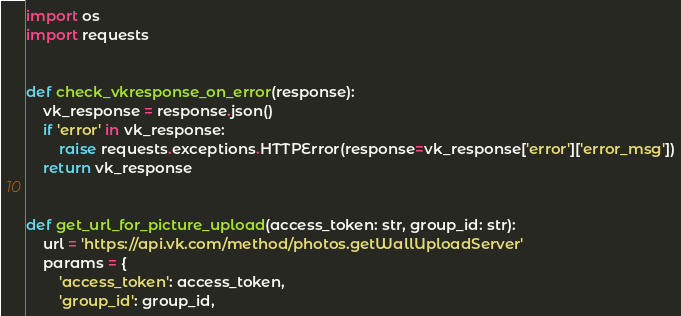<code> <loc_0><loc_0><loc_500><loc_500><_Python_>import os
import requests


def check_vkresponse_on_error(response):
    vk_response = response.json()
    if 'error' in vk_response:
        raise requests.exceptions.HTTPError(response=vk_response['error']['error_msg'])
    return vk_response


def get_url_for_picture_upload(access_token: str, group_id: str):
    url = 'https://api.vk.com/method/photos.getWallUploadServer'
    params = {
        'access_token': access_token,
        'group_id': group_id,</code> 